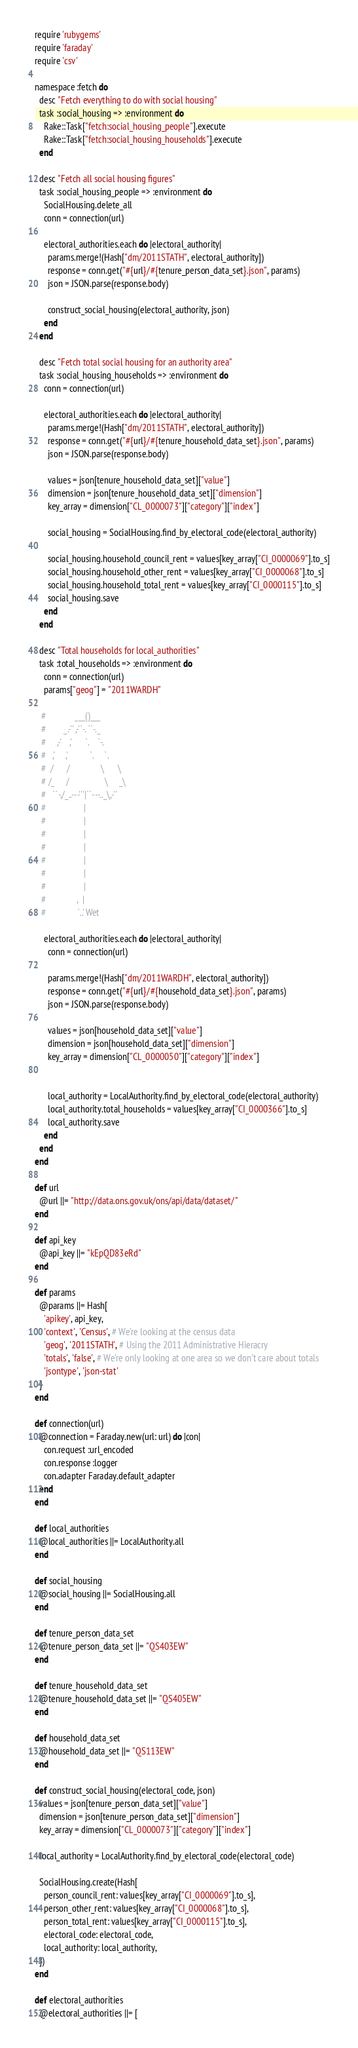<code> <loc_0><loc_0><loc_500><loc_500><_Ruby_>require 'rubygems'
require 'faraday'
require 'csv'

namespace :fetch do
  desc "Fetch everything to do with social housing"
  task :social_housing => :environment do
    Rake::Task["fetch:social_housing_people"].execute
    Rake::Task["fetch:social_housing_households"].execute
  end

  desc "Fetch all social housing figures"
  task :social_housing_people => :environment do
    SocialHousing.delete_all
    conn = connection(url)

    electoral_authorities.each do |electoral_authority|
      params.merge!(Hash["dm/2011STATH", electoral_authority])
      response = conn.get("#{url}/#{tenure_person_data_set}.json", params)
      json = JSON.parse(response.body)

      construct_social_housing(electoral_authority, json)
    end
  end

  desc "Fetch total social housing for an authority area"
  task :social_housing_households => :environment do
    conn = connection(url)

    electoral_authorities.each do |electoral_authority|
      params.merge!(Hash["dm/2011STATH", electoral_authority])
      response = conn.get("#{url}/#{tenure_household_data_set}.json", params)
      json = JSON.parse(response.body)

      values = json[tenure_household_data_set]["value"]
      dimension = json[tenure_household_data_set]["dimension"]
      key_array = dimension["CL_0000073"]["category"]["index"]

      social_housing = SocialHousing.find_by_electoral_code(electoral_authority)

      social_housing.household_council_rent = values[key_array["CI_0000069"].to_s]
      social_housing.household_other_rent = values[key_array["CI_0000068"].to_s]
      social_housing.household_total_rent = values[key_array["CI_0000115"].to_s]
      social_housing.save
    end
  end

  desc "Total households for local_authorities"
  task :total_households => :environment do
    conn = connection(url)
    params["geog"] = "2011WARDH"

   #             ___()___
   #        _.-'' ,-'`-. ``-._
   #     ,-'    ,'      `.    `-.
   #   ,'     ,'          `.     `.
   #  /      /              \      \
   # /_     /                \     _\
   #   ``-./_..---'''|``---.._\,-''
   #                 |
   #                 |
   #                 |
   #                 |
   #                 |
   #                 |
   #                 |
   #              ,  |
   #              `..' Wet

    electoral_authorities.each do |electoral_authority|
      conn = connection(url)

      params.merge!(Hash["dm/2011WARDH", electoral_authority])
      response = conn.get("#{url}/#{household_data_set}.json", params)
      json = JSON.parse(response.body)

      values = json[household_data_set]["value"]
      dimension = json[household_data_set]["dimension"]
      key_array = dimension["CL_0000050"]["category"]["index"]


      local_authority = LocalAuthority.find_by_electoral_code(electoral_authority)
      local_authority.total_households = values[key_array["CI_0000366"].to_s]
      local_authority.save
    end
  end
end

def url
  @url ||= "http://data.ons.gov.uk/ons/api/data/dataset/"
end

def api_key
  @api_key ||= "kEpQD83eRd"
end

def params
  @params ||= Hash[
    'apikey', api_key,
    'context', 'Census', # We're looking at the census data
    'geog', '2011STATH', # Using the 2011 Administrative Hieracry
    'totals', 'false', # We're only looking at one area so we don't care about totals
    'jsontype', 'json-stat'
  ]
end

def connection(url)
  @connection = Faraday.new(url: url) do |con|
    con.request :url_encoded
    con.response :logger
    con.adapter Faraday.default_adapter
  end
end

def local_authorities
  @local_authorities ||= LocalAuthority.all
end

def social_housing
  @social_housing ||= SocialHousing.all
end

def tenure_person_data_set
  @tenure_person_data_set ||= "QS403EW"
end

def tenure_household_data_set
  @tenure_household_data_set ||= "QS405EW"
end

def household_data_set
  @household_data_set ||= "QS113EW"
end

def construct_social_housing(electoral_code, json)
  values = json[tenure_person_data_set]["value"]
  dimension = json[tenure_person_data_set]["dimension"]
  key_array = dimension["CL_0000073"]["category"]["index"]

  local_authority = LocalAuthority.find_by_electoral_code(electoral_code)

  SocialHousing.create(Hash[
    person_council_rent: values[key_array["CI_0000069"].to_s],
    person_other_rent: values[key_array["CI_0000068"].to_s],
    person_total_rent: values[key_array["CI_0000115"].to_s],
    electoral_code: electoral_code,
    local_authority: local_authority,
  ])
end

def electoral_authorities
  @electoral_authorities ||= [</code> 